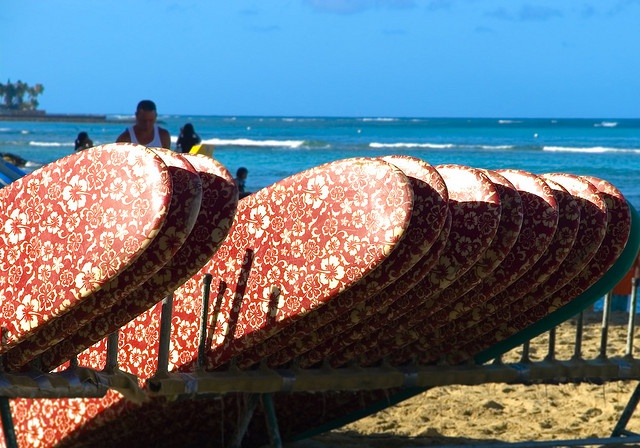Describe the objects in this image and their specific colors. I can see surfboard in lightblue, black, maroon, salmon, and gray tones, surfboard in lightblue, red, ivory, and salmon tones, surfboard in lightblue, black, white, maroon, and tan tones, surfboard in lightblue, black, maroon, white, and salmon tones, and surfboard in lightblue, black, maroon, and white tones in this image. 